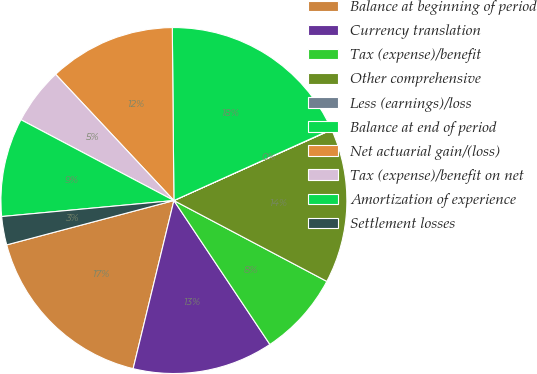<chart> <loc_0><loc_0><loc_500><loc_500><pie_chart><fcel>Balance at beginning of period<fcel>Currency translation<fcel>Tax (expense)/benefit<fcel>Other comprehensive<fcel>Less (earnings)/loss<fcel>Balance at end of period<fcel>Net actuarial gain/(loss)<fcel>Tax (expense)/benefit on net<fcel>Amortization of experience<fcel>Settlement losses<nl><fcel>17.09%<fcel>13.15%<fcel>7.9%<fcel>14.46%<fcel>0.03%<fcel>18.4%<fcel>11.84%<fcel>5.28%<fcel>9.21%<fcel>2.65%<nl></chart> 